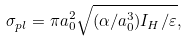<formula> <loc_0><loc_0><loc_500><loc_500>\sigma _ { p l } = \pi a _ { 0 } ^ { 2 } \sqrt { ( \alpha / a _ { 0 } ^ { 3 } ) I _ { H } / \varepsilon } ,</formula> 